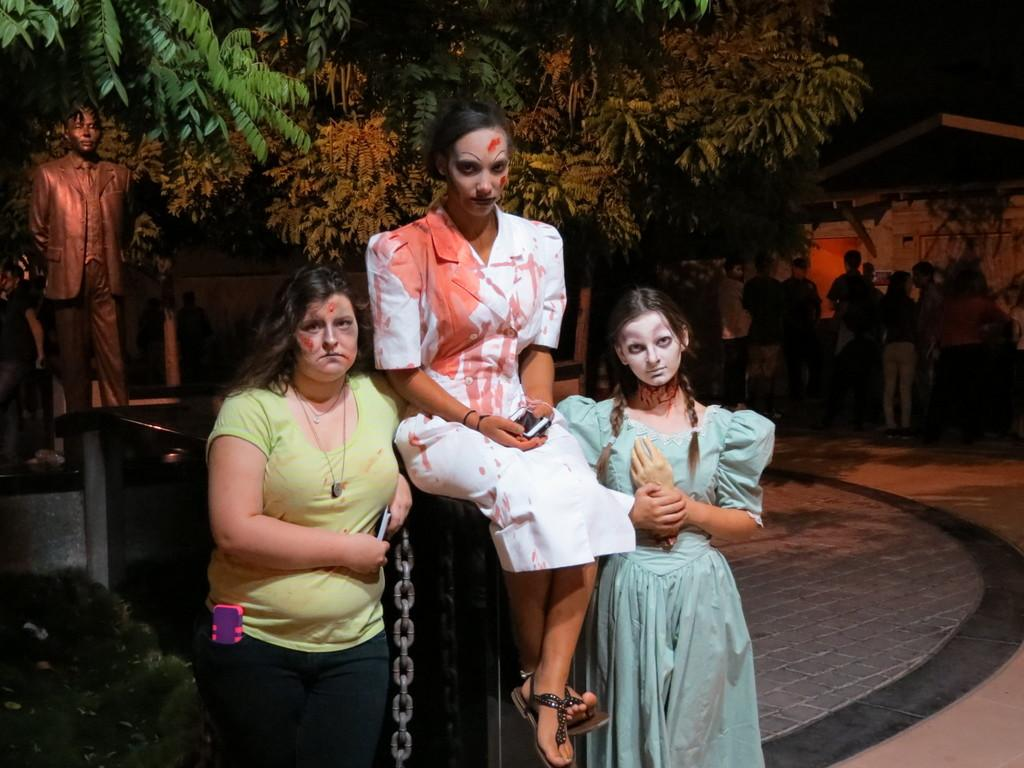How many women are in the image? There are three women in the image. What are the positions of the women in the image? Two of the women are standing, and one woman is sitting on a bench. What can be seen in the background of the image? There is a statue and trees in the background of the image, as well as people standing. What is the error rate of the range finder in the image? There is no range finder present in the image, so it is not possible to determine an error rate. 